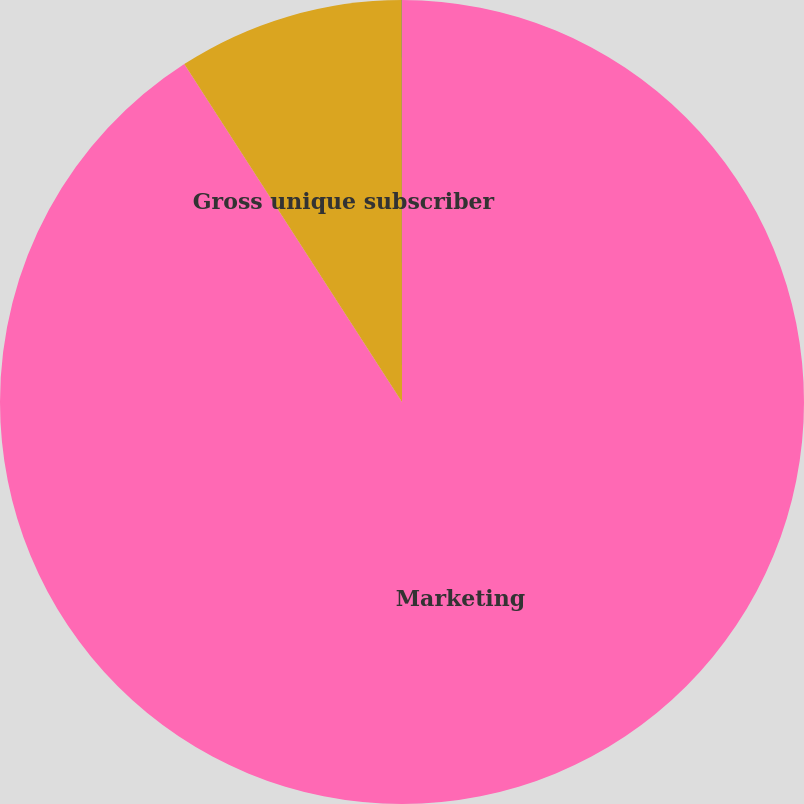<chart> <loc_0><loc_0><loc_500><loc_500><pie_chart><fcel>Marketing<fcel>Gross unique subscriber<fcel>Subscriber acquisition cost<nl><fcel>90.89%<fcel>9.1%<fcel>0.01%<nl></chart> 